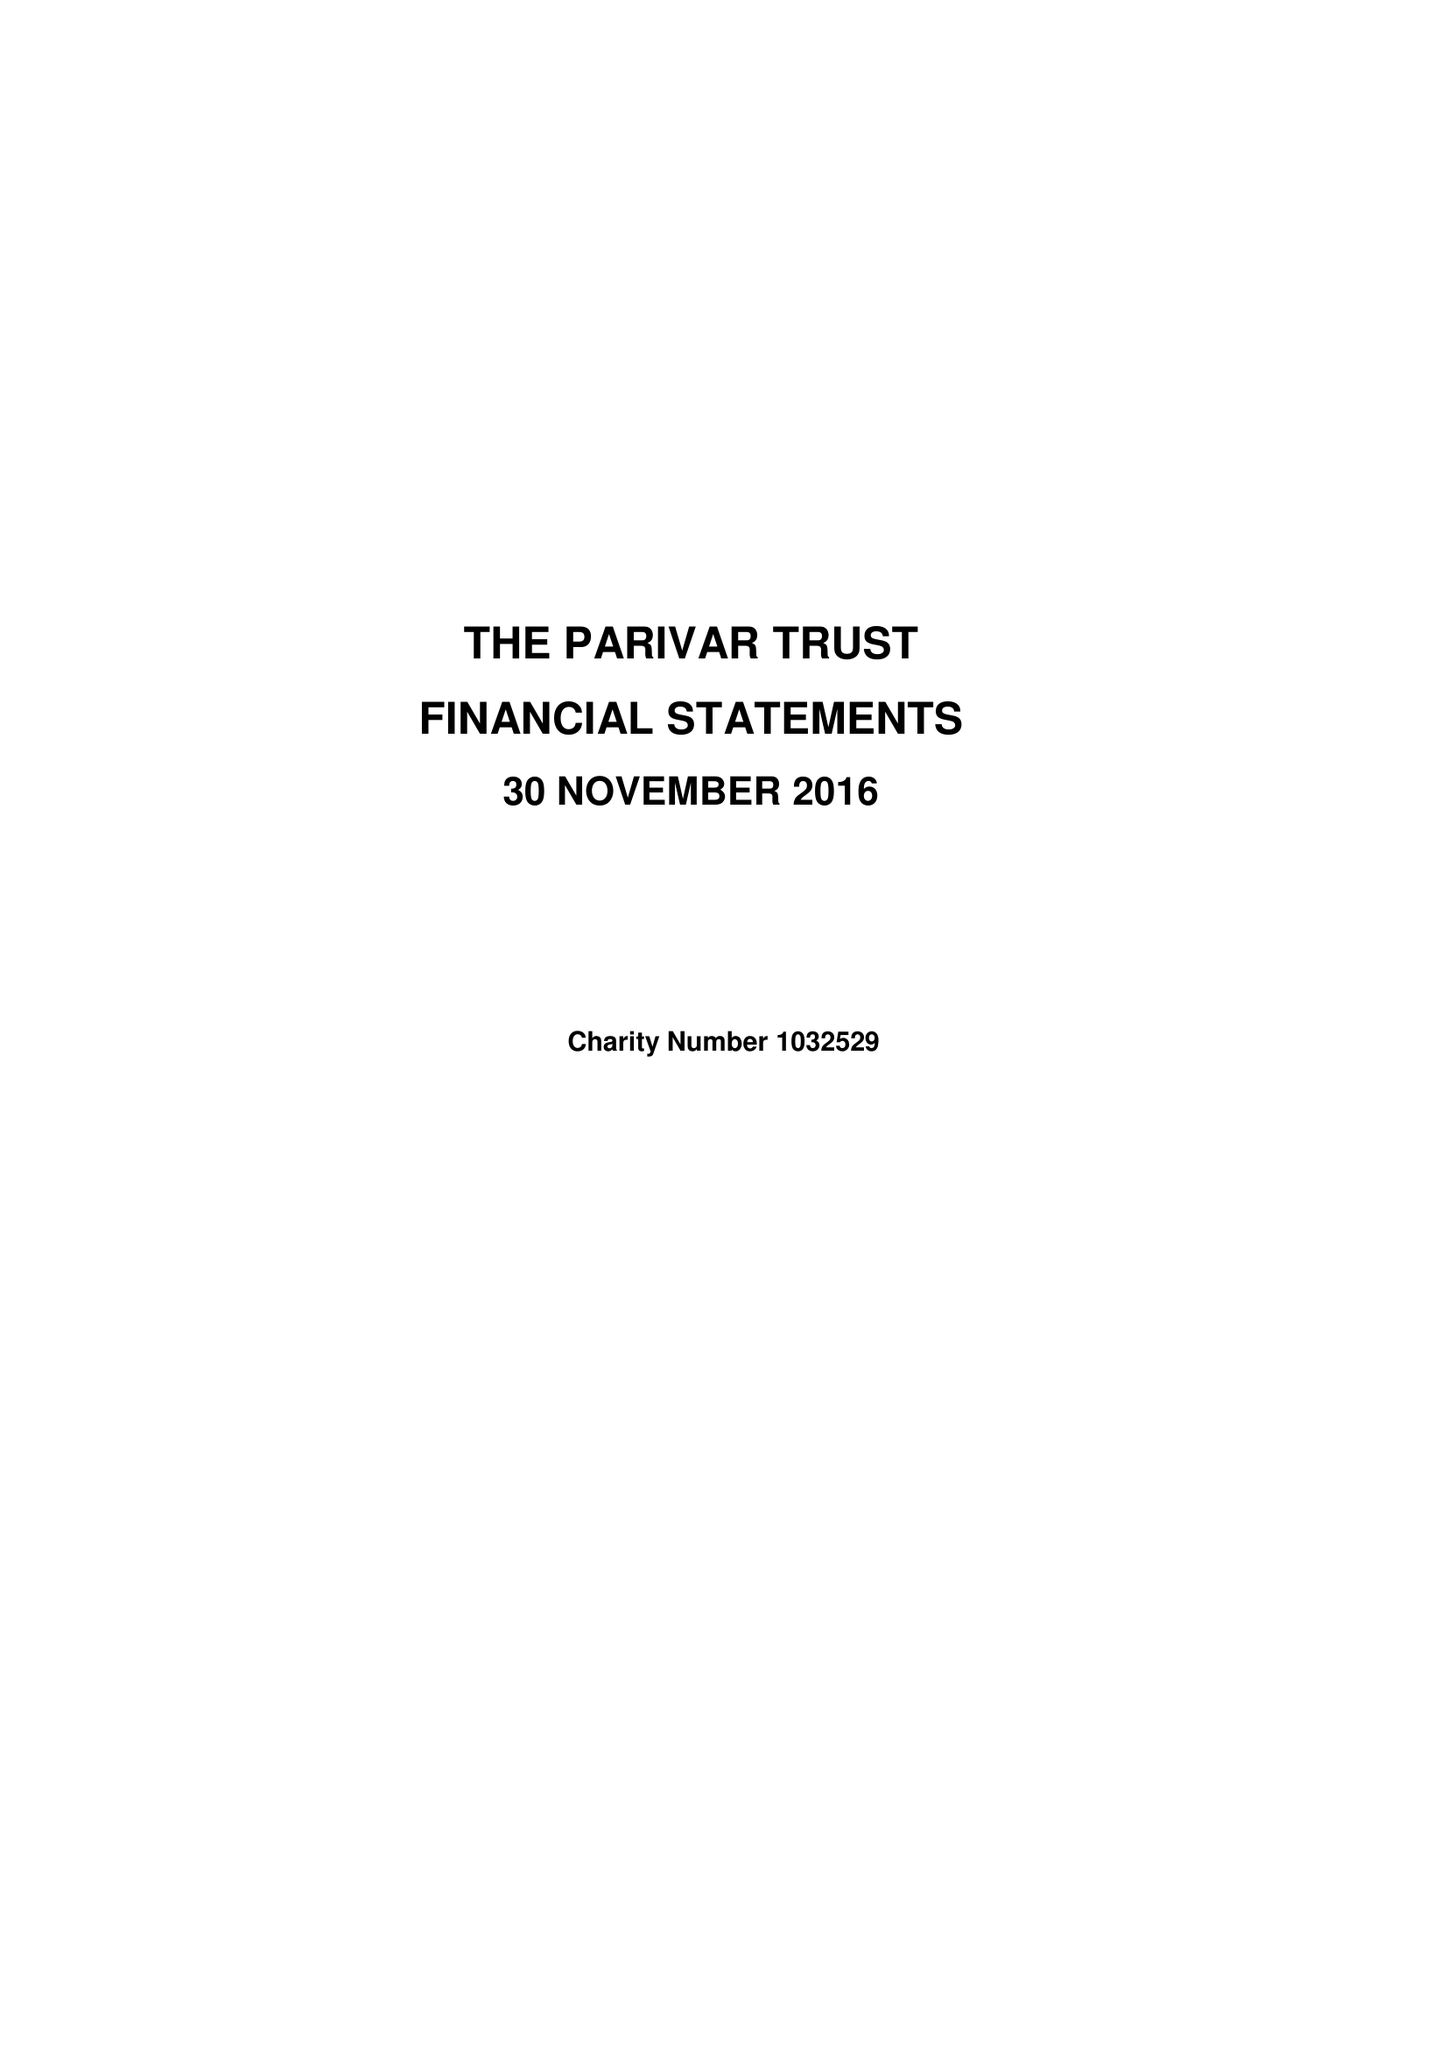What is the value for the charity_number?
Answer the question using a single word or phrase. 1032529 